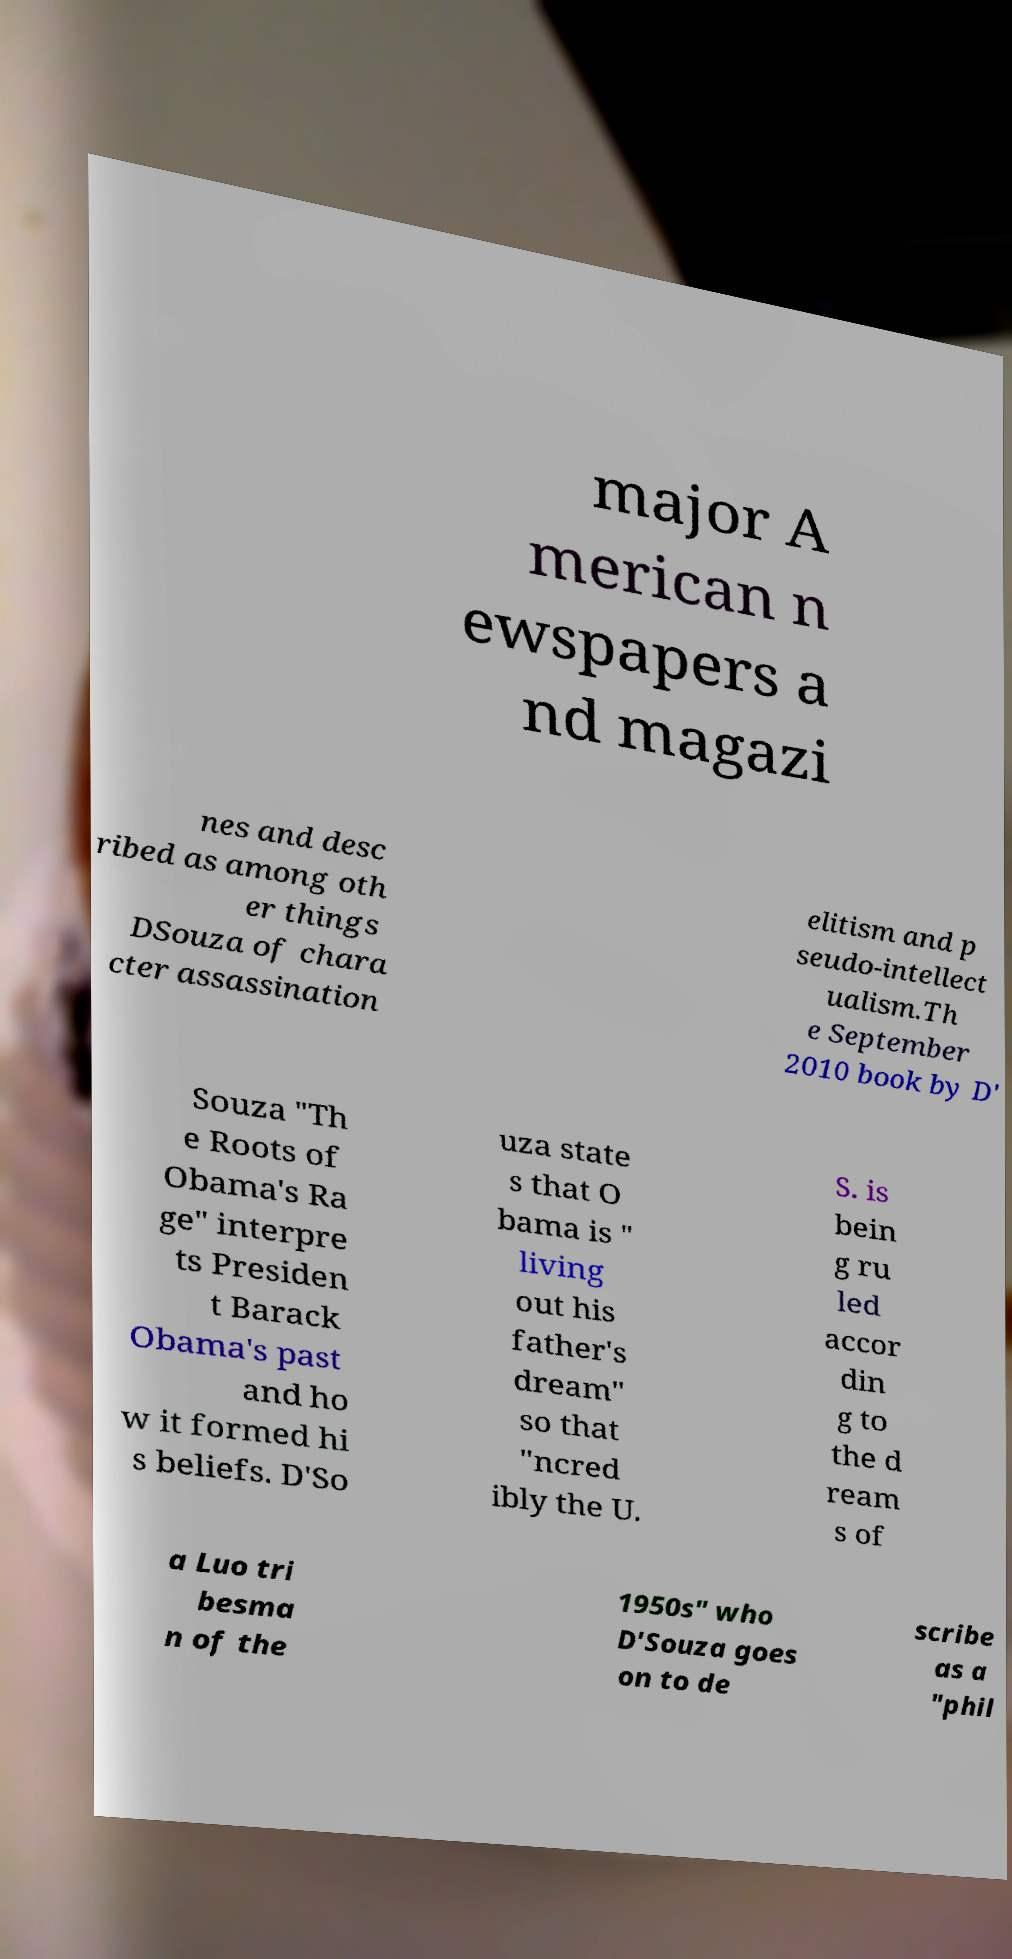Please identify and transcribe the text found in this image. major A merican n ewspapers a nd magazi nes and desc ribed as among oth er things DSouza of chara cter assassination elitism and p seudo-intellect ualism.Th e September 2010 book by D' Souza "Th e Roots of Obama's Ra ge" interpre ts Presiden t Barack Obama's past and ho w it formed hi s beliefs. D'So uza state s that O bama is " living out his father's dream" so that "ncred ibly the U. S. is bein g ru led accor din g to the d ream s of a Luo tri besma n of the 1950s" who D'Souza goes on to de scribe as a "phil 